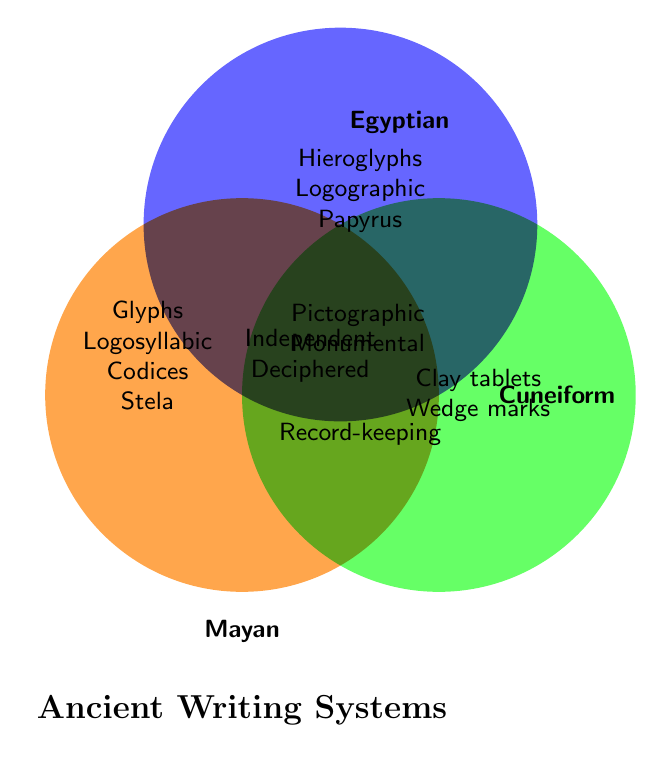What common features do Mayan and Egyptian writing systems share? The figure shows that the overlapping area between Mayan and Egyptian has "Pictographic elements" and "Monumental inscriptions."
Answer: Pictographic elements, Monumental inscriptions Which three writing systems share common characteristics that were developed independently and deciphered in modern times? At the center where all three circles overlap, we find "Developed independently" and "Deciphered in modern times," indicating these characteristics are shared by Mayan, Egyptian, and Cuneiform scripts.
Answer: Mayan, Egyptian, Cuneiform How is the Mayan writing system different from Cuneiform? The figure shows that the Mayan writing system includes features like "Glyphs," "Logosyllabic," "Codices," and "Stela inscriptions," while Cuneiform includes "Clay tablets" and "Wedge-shaped marks."
Answer: Mayan uses glyphs, logosyllabic writing, codices, and stela inscriptions; Cuneiform uses clay tablets and wedge-shaped marks What unique element is associated with the Egyptian writing system that is not present in Mayan and Cuneiform? The Egyptian area exclusively lists "Hieroglyphs," "Logographic," and "Papyrus scrolls."
Answer: Hieroglyphs, Logographic, Papyrus scrolls Which writing systems were used for record-keeping? The area where Mayan and Cuneiform overlap shows "Used for record-keeping."
Answer: Mayan, Cuneiform What feature is unique to the Cuneiform writing system compared to the Mayan and Egyptian scripts? The exclusive Cuneiform area lists "Clay tablets" and "Wedge-shaped marks."
Answer: Clay tablets, Wedge-shaped marks Which two writing systems share the characteristic of having monumental inscriptions? The overlapping area between Mayan and Egyptian indicates that both have "Monumental inscriptions."
Answer: Mayan, Egyptian What are the distinguishing features of the Mayan writing system? The exclusive Mayan area shows "Glyphs," "Logosyllabic," "Codices," and "Stela inscriptions."
Answer: Glyphs, Logosyllabic, Codices, Stela inscriptions 